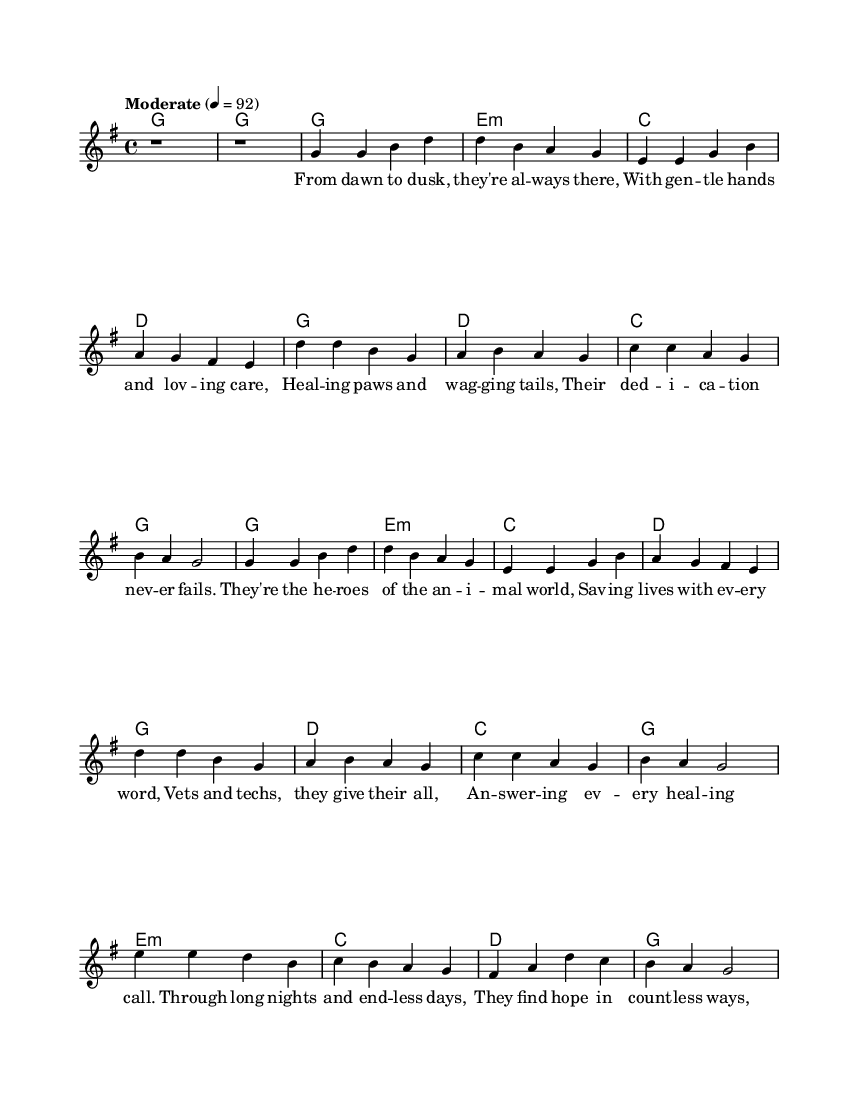What is the key signature of this music? The key signature is G major, which has one sharp (F#). This is indicated at the beginning of the staff.
Answer: G major What is the time signature of this piece? The time signature is 4/4, which means there are four beats in each measure and a quarter note receives one beat. This is indicated at the beginning of the score.
Answer: 4/4 What is the tempo marking given for the piece? The tempo marking is "Moderate," which is indicated above the staff with a tempo notation of 4 = 92. This shows a moderate pace for the music.
Answer: Moderate How many verses are in this song? The song contains two verses; they can be identified as verse one and verse two in the lyrics section. Each verse has distinct lines dedicated to it.
Answer: Two What is the primary theme of the lyrics? The primary theme of the lyrics celebrates the dedication of animal care professionals, highlighting their compassion and commitment to veterinary work. This is evident from the content of the lyrics in both verses and the chorus.
Answer: Dedication of animal care professionals What chord is played during the chorus? The chord played during the chorus primarily alternates between G, D, and C chords, as indicated in the harmony section, providing a foundational structure that supports the melody.
Answer: G, D, C How does the bridge differ from the verses and chorus? The bridge introduces different lyrics and a new emotional perspective on the care provided by animal professionals, suggesting a deeper personal commitment as compared to the previous sections. It uses distinct melodic and harmonic elements as well.
Answer: Provides a deeper perspective 